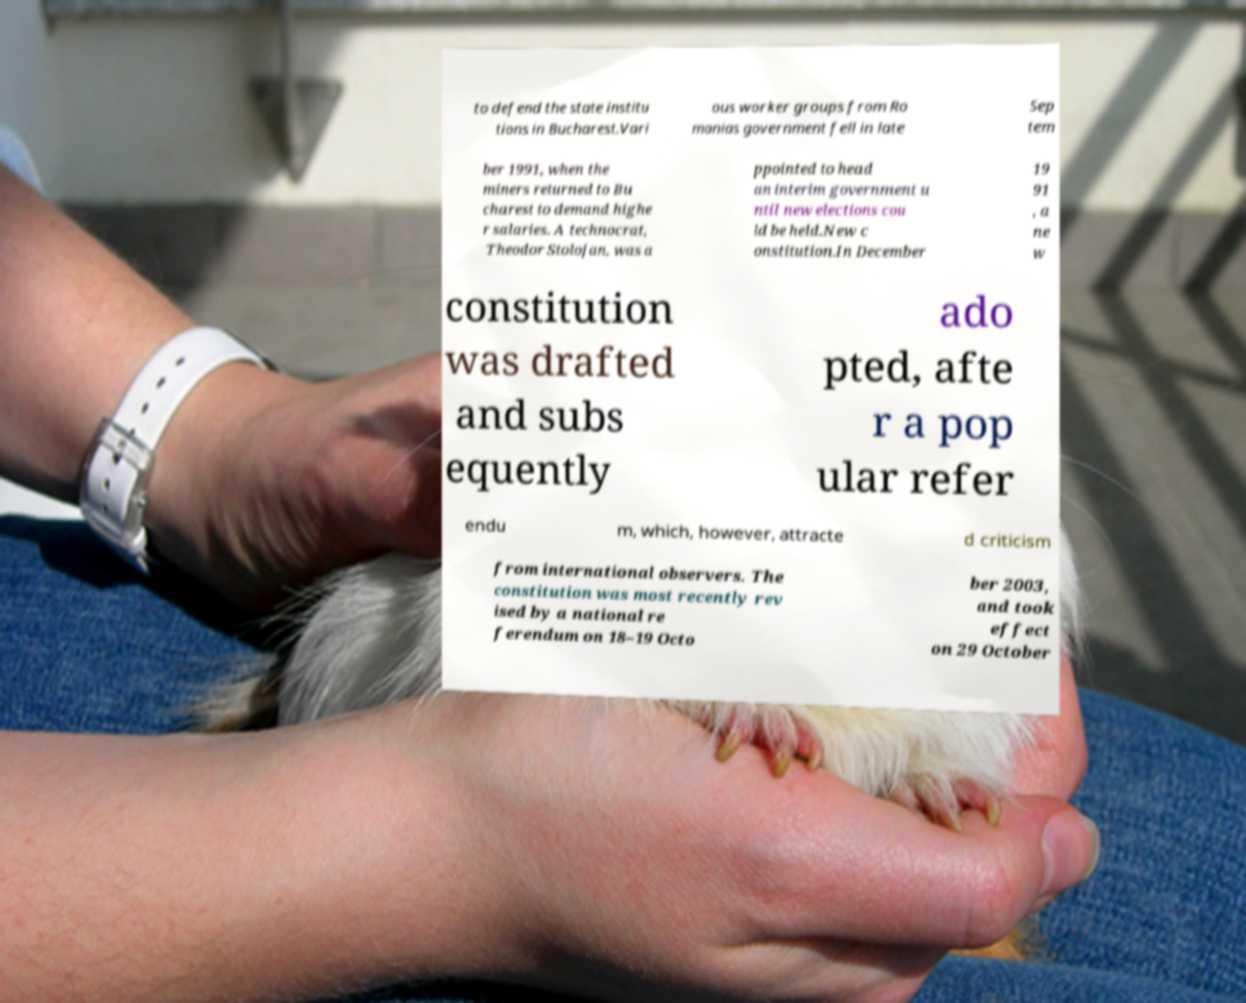Please read and relay the text visible in this image. What does it say? to defend the state institu tions in Bucharest.Vari ous worker groups from Ro manias government fell in late Sep tem ber 1991, when the miners returned to Bu charest to demand highe r salaries. A technocrat, Theodor Stolojan, was a ppointed to head an interim government u ntil new elections cou ld be held.New c onstitution.In December 19 91 , a ne w constitution was drafted and subs equently ado pted, afte r a pop ular refer endu m, which, however, attracte d criticism from international observers. The constitution was most recently rev ised by a national re ferendum on 18–19 Octo ber 2003, and took effect on 29 October 